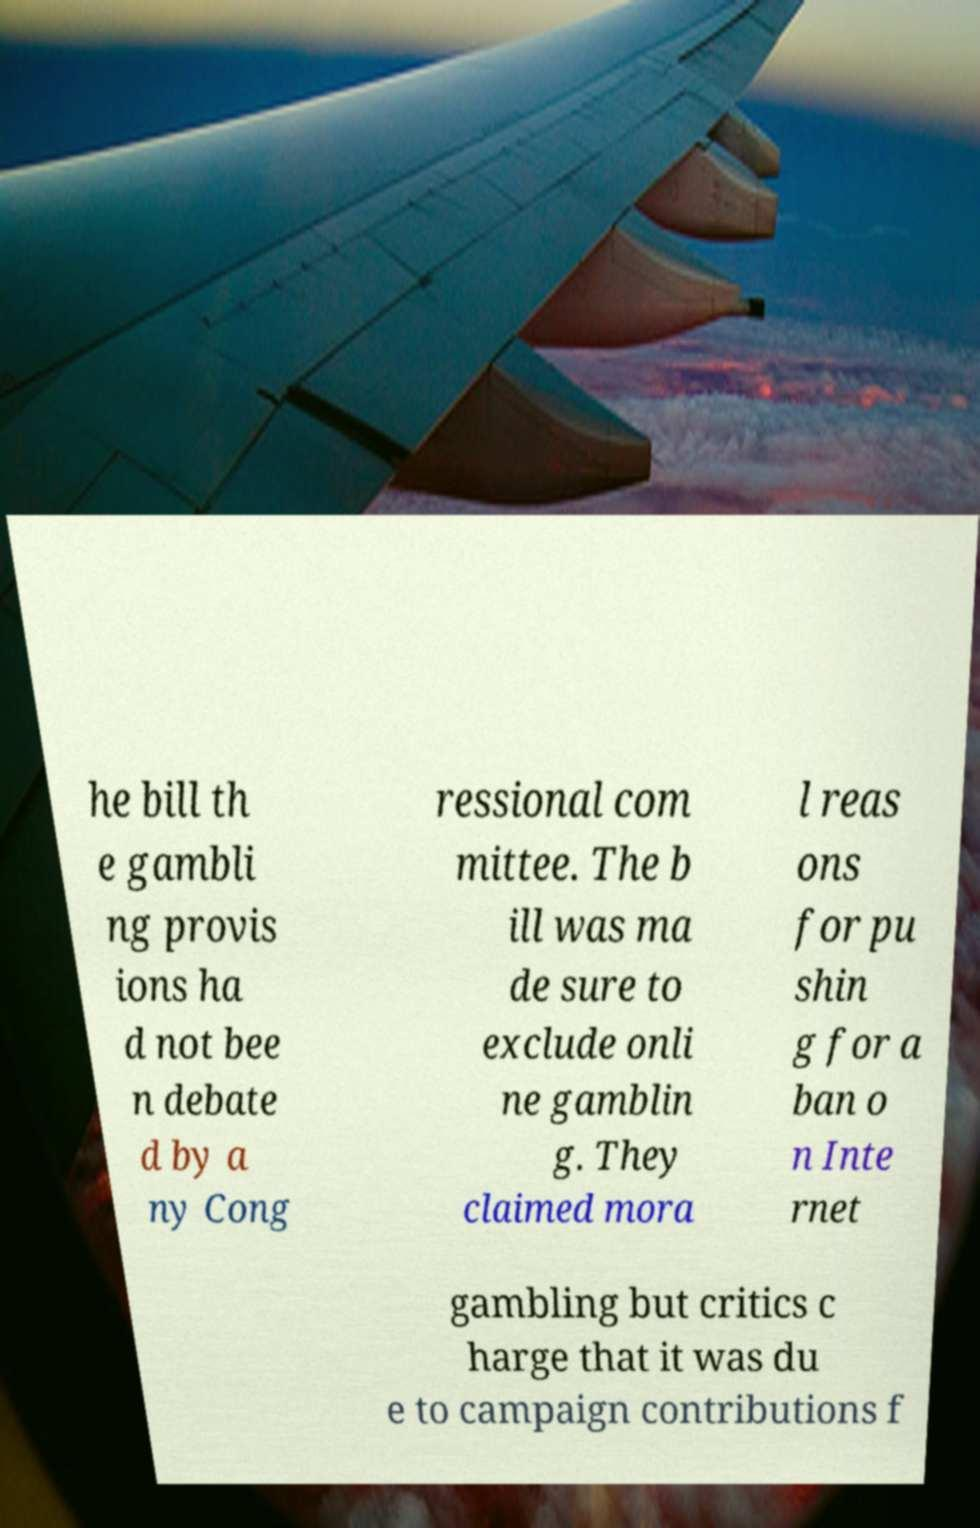Can you read and provide the text displayed in the image?This photo seems to have some interesting text. Can you extract and type it out for me? he bill th e gambli ng provis ions ha d not bee n debate d by a ny Cong ressional com mittee. The b ill was ma de sure to exclude onli ne gamblin g. They claimed mora l reas ons for pu shin g for a ban o n Inte rnet gambling but critics c harge that it was du e to campaign contributions f 